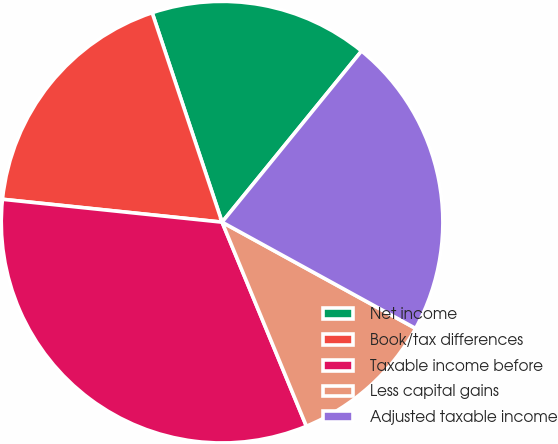Convert chart to OTSL. <chart><loc_0><loc_0><loc_500><loc_500><pie_chart><fcel>Net income<fcel>Book/tax differences<fcel>Taxable income before<fcel>Less capital gains<fcel>Adjusted taxable income<nl><fcel>16.01%<fcel>18.22%<fcel>32.89%<fcel>10.77%<fcel>22.11%<nl></chart> 